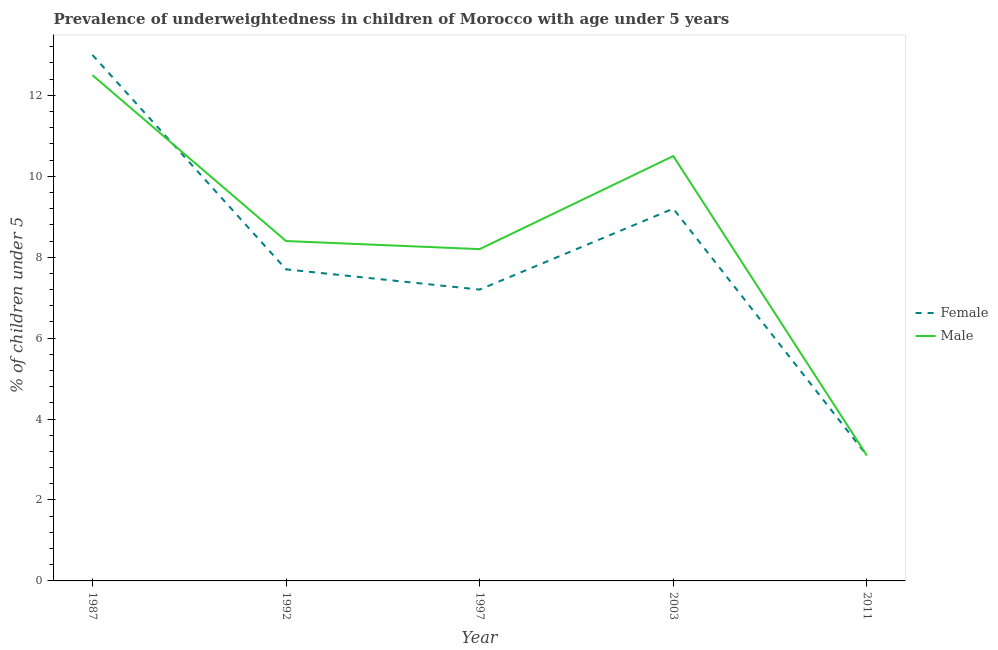Does the line corresponding to percentage of underweighted female children intersect with the line corresponding to percentage of underweighted male children?
Give a very brief answer. Yes. Is the number of lines equal to the number of legend labels?
Ensure brevity in your answer.  Yes. What is the percentage of underweighted female children in 1997?
Make the answer very short. 7.2. Across all years, what is the maximum percentage of underweighted male children?
Provide a succinct answer. 12.5. Across all years, what is the minimum percentage of underweighted female children?
Your answer should be very brief. 3.1. In which year was the percentage of underweighted female children maximum?
Your answer should be compact. 1987. What is the total percentage of underweighted male children in the graph?
Provide a short and direct response. 42.7. What is the difference between the percentage of underweighted male children in 2003 and that in 2011?
Offer a terse response. 7.4. What is the difference between the percentage of underweighted female children in 1997 and the percentage of underweighted male children in 1992?
Provide a succinct answer. -1.2. What is the average percentage of underweighted male children per year?
Ensure brevity in your answer.  8.54. In the year 2011, what is the difference between the percentage of underweighted female children and percentage of underweighted male children?
Your response must be concise. 0. In how many years, is the percentage of underweighted male children greater than 2.8 %?
Your answer should be very brief. 5. What is the ratio of the percentage of underweighted male children in 1992 to that in 2011?
Make the answer very short. 2.71. Is the difference between the percentage of underweighted male children in 1987 and 1992 greater than the difference between the percentage of underweighted female children in 1987 and 1992?
Provide a succinct answer. No. What is the difference between the highest and the lowest percentage of underweighted male children?
Provide a short and direct response. 9.4. In how many years, is the percentage of underweighted male children greater than the average percentage of underweighted male children taken over all years?
Offer a terse response. 2. Is the percentage of underweighted female children strictly less than the percentage of underweighted male children over the years?
Offer a very short reply. No. How many lines are there?
Offer a terse response. 2. How many years are there in the graph?
Provide a short and direct response. 5. What is the difference between two consecutive major ticks on the Y-axis?
Your answer should be compact. 2. Does the graph contain any zero values?
Offer a very short reply. No. Where does the legend appear in the graph?
Make the answer very short. Center right. How are the legend labels stacked?
Provide a short and direct response. Vertical. What is the title of the graph?
Your response must be concise. Prevalence of underweightedness in children of Morocco with age under 5 years. Does "International Visitors" appear as one of the legend labels in the graph?
Make the answer very short. No. What is the label or title of the X-axis?
Offer a terse response. Year. What is the label or title of the Y-axis?
Your answer should be compact.  % of children under 5. What is the  % of children under 5 in Female in 1987?
Offer a very short reply. 13. What is the  % of children under 5 of Male in 1987?
Offer a very short reply. 12.5. What is the  % of children under 5 in Female in 1992?
Keep it short and to the point. 7.7. What is the  % of children under 5 of Male in 1992?
Ensure brevity in your answer.  8.4. What is the  % of children under 5 of Female in 1997?
Your answer should be compact. 7.2. What is the  % of children under 5 in Male in 1997?
Provide a short and direct response. 8.2. What is the  % of children under 5 in Female in 2003?
Your response must be concise. 9.2. What is the  % of children under 5 in Female in 2011?
Keep it short and to the point. 3.1. What is the  % of children under 5 in Male in 2011?
Give a very brief answer. 3.1. Across all years, what is the maximum  % of children under 5 of Male?
Your response must be concise. 12.5. Across all years, what is the minimum  % of children under 5 in Female?
Provide a succinct answer. 3.1. Across all years, what is the minimum  % of children under 5 of Male?
Provide a short and direct response. 3.1. What is the total  % of children under 5 of Female in the graph?
Provide a succinct answer. 40.2. What is the total  % of children under 5 of Male in the graph?
Your answer should be very brief. 42.7. What is the difference between the  % of children under 5 of Female in 1987 and that in 1992?
Make the answer very short. 5.3. What is the difference between the  % of children under 5 in Male in 1987 and that in 1997?
Keep it short and to the point. 4.3. What is the difference between the  % of children under 5 of Female in 1987 and that in 2003?
Offer a very short reply. 3.8. What is the difference between the  % of children under 5 in Female in 1992 and that in 1997?
Offer a terse response. 0.5. What is the difference between the  % of children under 5 in Female in 1992 and that in 2011?
Offer a terse response. 4.6. What is the difference between the  % of children under 5 in Female in 1997 and that in 2003?
Ensure brevity in your answer.  -2. What is the difference between the  % of children under 5 in Female in 1997 and that in 2011?
Provide a short and direct response. 4.1. What is the difference between the  % of children under 5 in Male in 1997 and that in 2011?
Offer a very short reply. 5.1. What is the difference between the  % of children under 5 of Female in 1987 and the  % of children under 5 of Male in 2003?
Give a very brief answer. 2.5. What is the difference between the  % of children under 5 in Female in 1987 and the  % of children under 5 in Male in 2011?
Ensure brevity in your answer.  9.9. What is the average  % of children under 5 of Female per year?
Keep it short and to the point. 8.04. What is the average  % of children under 5 in Male per year?
Make the answer very short. 8.54. In the year 1992, what is the difference between the  % of children under 5 in Female and  % of children under 5 in Male?
Offer a terse response. -0.7. What is the ratio of the  % of children under 5 of Female in 1987 to that in 1992?
Your response must be concise. 1.69. What is the ratio of the  % of children under 5 in Male in 1987 to that in 1992?
Provide a short and direct response. 1.49. What is the ratio of the  % of children under 5 of Female in 1987 to that in 1997?
Your answer should be compact. 1.81. What is the ratio of the  % of children under 5 in Male in 1987 to that in 1997?
Provide a succinct answer. 1.52. What is the ratio of the  % of children under 5 in Female in 1987 to that in 2003?
Ensure brevity in your answer.  1.41. What is the ratio of the  % of children under 5 in Male in 1987 to that in 2003?
Offer a terse response. 1.19. What is the ratio of the  % of children under 5 of Female in 1987 to that in 2011?
Provide a succinct answer. 4.19. What is the ratio of the  % of children under 5 of Male in 1987 to that in 2011?
Your answer should be very brief. 4.03. What is the ratio of the  % of children under 5 in Female in 1992 to that in 1997?
Your response must be concise. 1.07. What is the ratio of the  % of children under 5 in Male in 1992 to that in 1997?
Ensure brevity in your answer.  1.02. What is the ratio of the  % of children under 5 in Female in 1992 to that in 2003?
Make the answer very short. 0.84. What is the ratio of the  % of children under 5 of Female in 1992 to that in 2011?
Make the answer very short. 2.48. What is the ratio of the  % of children under 5 of Male in 1992 to that in 2011?
Provide a succinct answer. 2.71. What is the ratio of the  % of children under 5 in Female in 1997 to that in 2003?
Your response must be concise. 0.78. What is the ratio of the  % of children under 5 in Male in 1997 to that in 2003?
Your answer should be very brief. 0.78. What is the ratio of the  % of children under 5 of Female in 1997 to that in 2011?
Offer a terse response. 2.32. What is the ratio of the  % of children under 5 of Male in 1997 to that in 2011?
Offer a terse response. 2.65. What is the ratio of the  % of children under 5 in Female in 2003 to that in 2011?
Keep it short and to the point. 2.97. What is the ratio of the  % of children under 5 in Male in 2003 to that in 2011?
Keep it short and to the point. 3.39. 